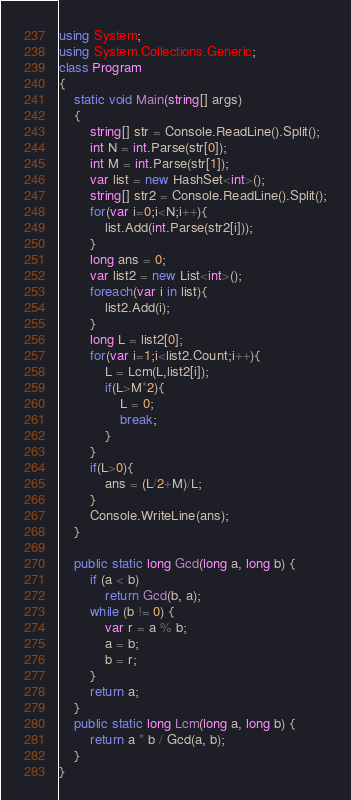<code> <loc_0><loc_0><loc_500><loc_500><_C#_>using System;
using System.Collections.Generic;
class Program
{
	static void Main(string[] args)
	{
		string[] str = Console.ReadLine().Split();
		int N = int.Parse(str[0]);
		int M = int.Parse(str[1]);
		var list = new HashSet<int>();
		string[] str2 = Console.ReadLine().Split();
		for(var i=0;i<N;i++){
			list.Add(int.Parse(str2[i]));
		}
		long ans = 0;
		var list2 = new List<int>();
		foreach(var i in list){
			list2.Add(i);
		}
		long L = list2[0];
		for(var i=1;i<list2.Count;i++){
			L = Lcm(L,list2[i]);
			if(L>M*2){
				L = 0;
				break;
			}
		}
		if(L>0){
			ans = (L/2+M)/L;
		}
		Console.WriteLine(ans);
	}
	
	public static long Gcd(long a, long b) {
		if (a < b)
			return Gcd(b, a);
		while (b != 0) {
			var r = a % b;
			a = b;
			b = r;
		}
		return a;
	}
	public static long Lcm(long a, long b) {
        return a * b / Gcd(a, b);
    }
}</code> 